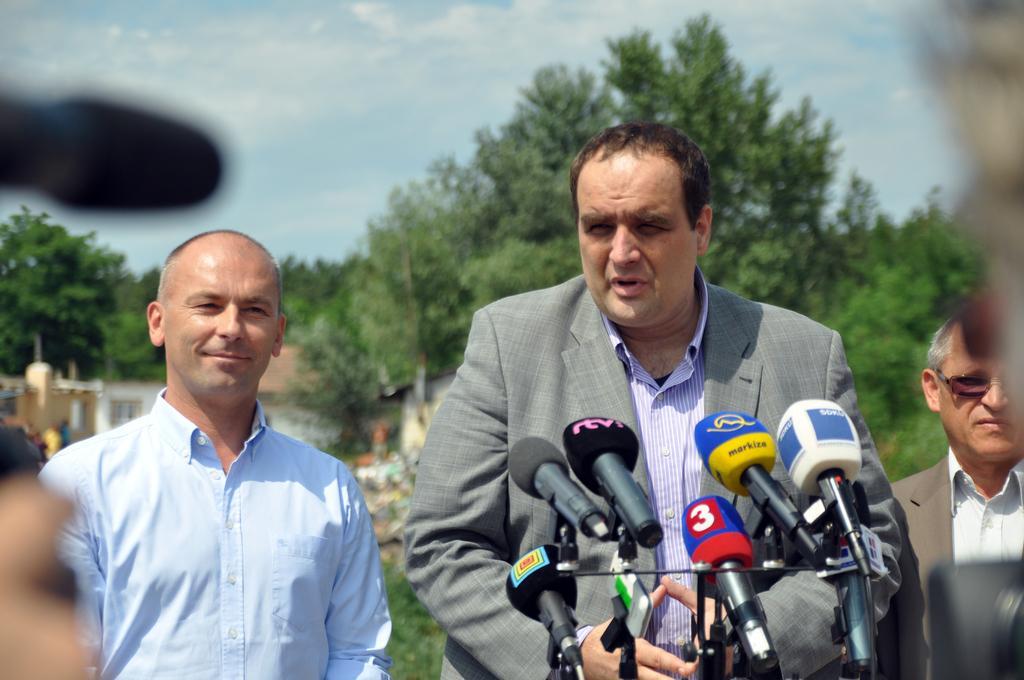Please provide a concise description of this image. There are three men standing. These are the mikes, which are kept on a stand. In the background, I can see the trees and houses. This is the sky. On the left side of the image, that looks like a mike. 